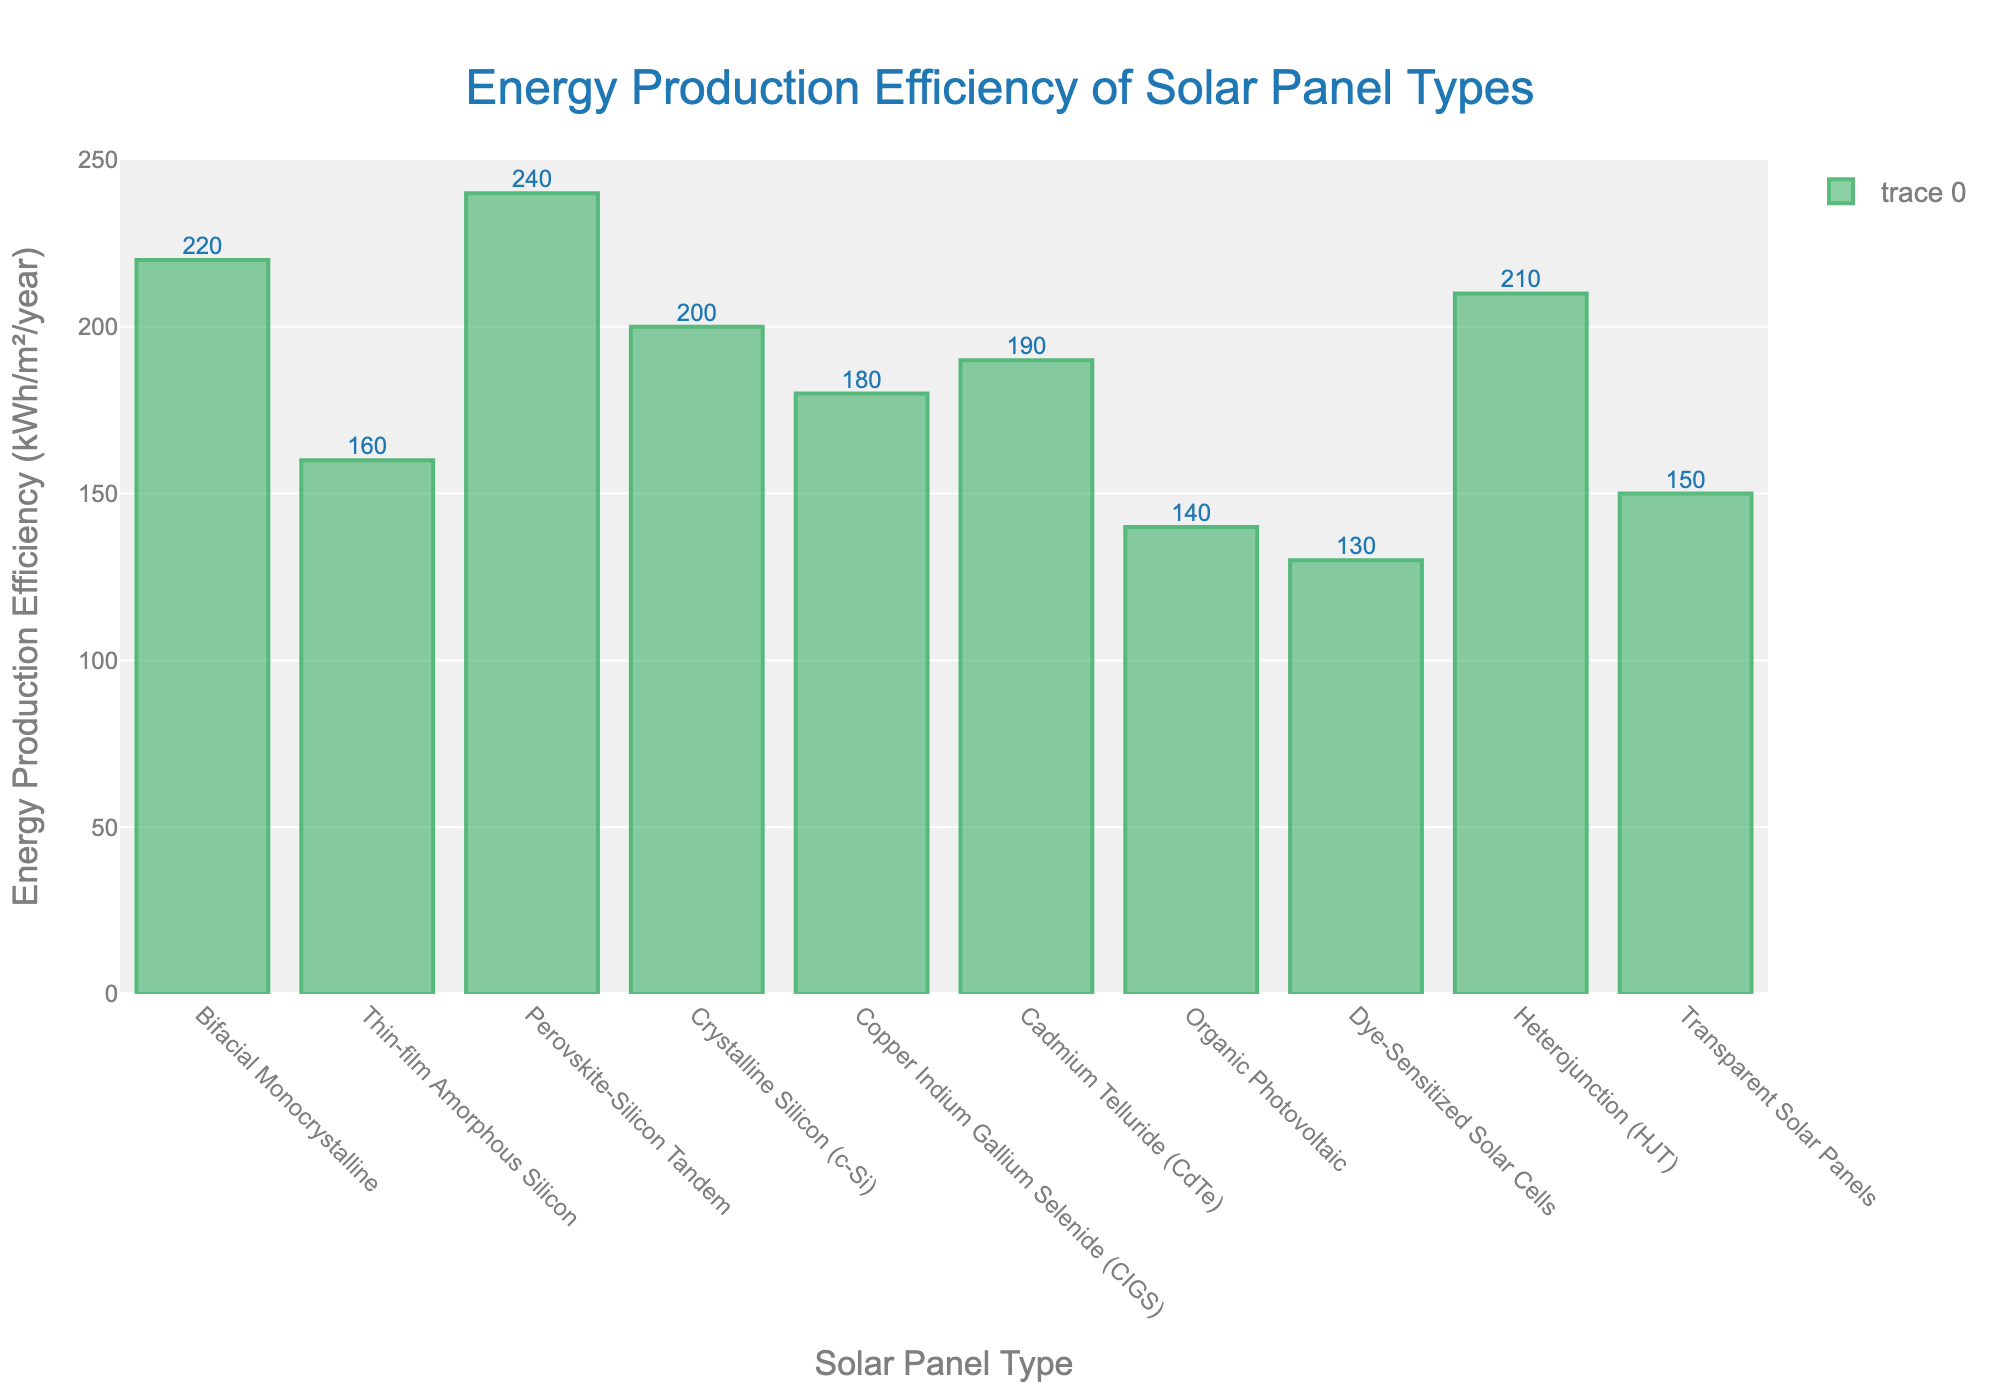Which solar panel type has the highest energy production efficiency? By observing the heights of the bars in the figure, the 'Perovskite-Silicon Tandem' solar panel type has the highest bar, indicating that it has the highest energy production efficiency of 240 kWh/m²/year.
Answer: Perovskite-Silicon Tandem What is the difference in energy production efficiency between Thin-film Amorphous Silicon and Cadmium Telluride (CdTe)? From the figure, the energy production efficiency of Thin-film Amorphous Silicon is 160 kWh/m²/year and that of Cadmium Telluride (CdTe) is 190 kWh/m²/year. The difference can be calculated as 190 - 160 = 30 kWh/m²/year.
Answer: 30 kWh/m²/year Which solar panel type has the least energy production efficiency? By observing the heights of the bars in the figure, the 'Dye-Sensitized Solar Cells' panel type has the shortest bar, indicating the least energy production efficiency of 130 kWh/m²/year.
Answer: Dye-Sensitized Solar Cells What is the average energy production efficiency of Bifacial Monocrystalline, Crystalline Silicon (c-Si), and Heterojunction (HJT) panels? The energy production efficiency values for Bifacial Monocrystalline, Crystalline Silicon (c-Si), and Heterojunction (HJT) panels are 220 kWh/m²/year, 200 kWh/m²/year, and 210 kWh/m²/year respectively. The average can be calculated as (220 + 200 + 210) / 3 = 210 kWh/m²/year.
Answer: 210 kWh/m²/year How many solar panel types have an energy production efficiency greater than 200 kWh/m²/year? Observing the figure, the solar panel types with an energy production efficiency greater than 200 kWh/m²/year are Bifacial Monocrystalline (220), Perovskite-Silicon Tandem (240), and Heterojunction (HJT) (210). Three solar panel types fit this criterion.
Answer: 3 What is the total energy production efficiency for Copper Indium Gallium Selenide (CIGS) and Transparent Solar Panels combined? The energy production efficiency of Copper Indium Gallium Selenide (CIGS) is 180 kWh/m²/year and Transparent Solar Panels is 150 kWh/m²/year. The total is calculated as 180 + 150 = 330 kWh/m²/year.
Answer: 330 kWh/m²/year Are there any solar panel types with equal energy production efficiency values? Scanning the bars in the figure, no two solar panel types have the exact same height, indicating that no solar panel types have equal energy production efficiency values.
Answer: No Which has a higher energy production efficiency: Organic Photovoltaic or Crystalline Silicon (c-Si)? By comparing the heights of their respective bars, Crystalline Silicon (c-Si) has an energy production efficiency of 200 kWh/m²/year, which is higher than Organic Photovoltaic at 140 kWh/m²/year.
Answer: Crystalline Silicon (c-Si) What is the combined energy production efficiency of the three lowest-performing solar panel types? The three solar panel types with the lowest energy production efficiencies are Dye-Sensitized Solar Cells (130), Organic Photovoltaic (140), and Transparent Solar Panels (150). The total can be calculated as 130 + 140 + 150 = 420 kWh/m²/year.
Answer: 420 kWh/m²/year 